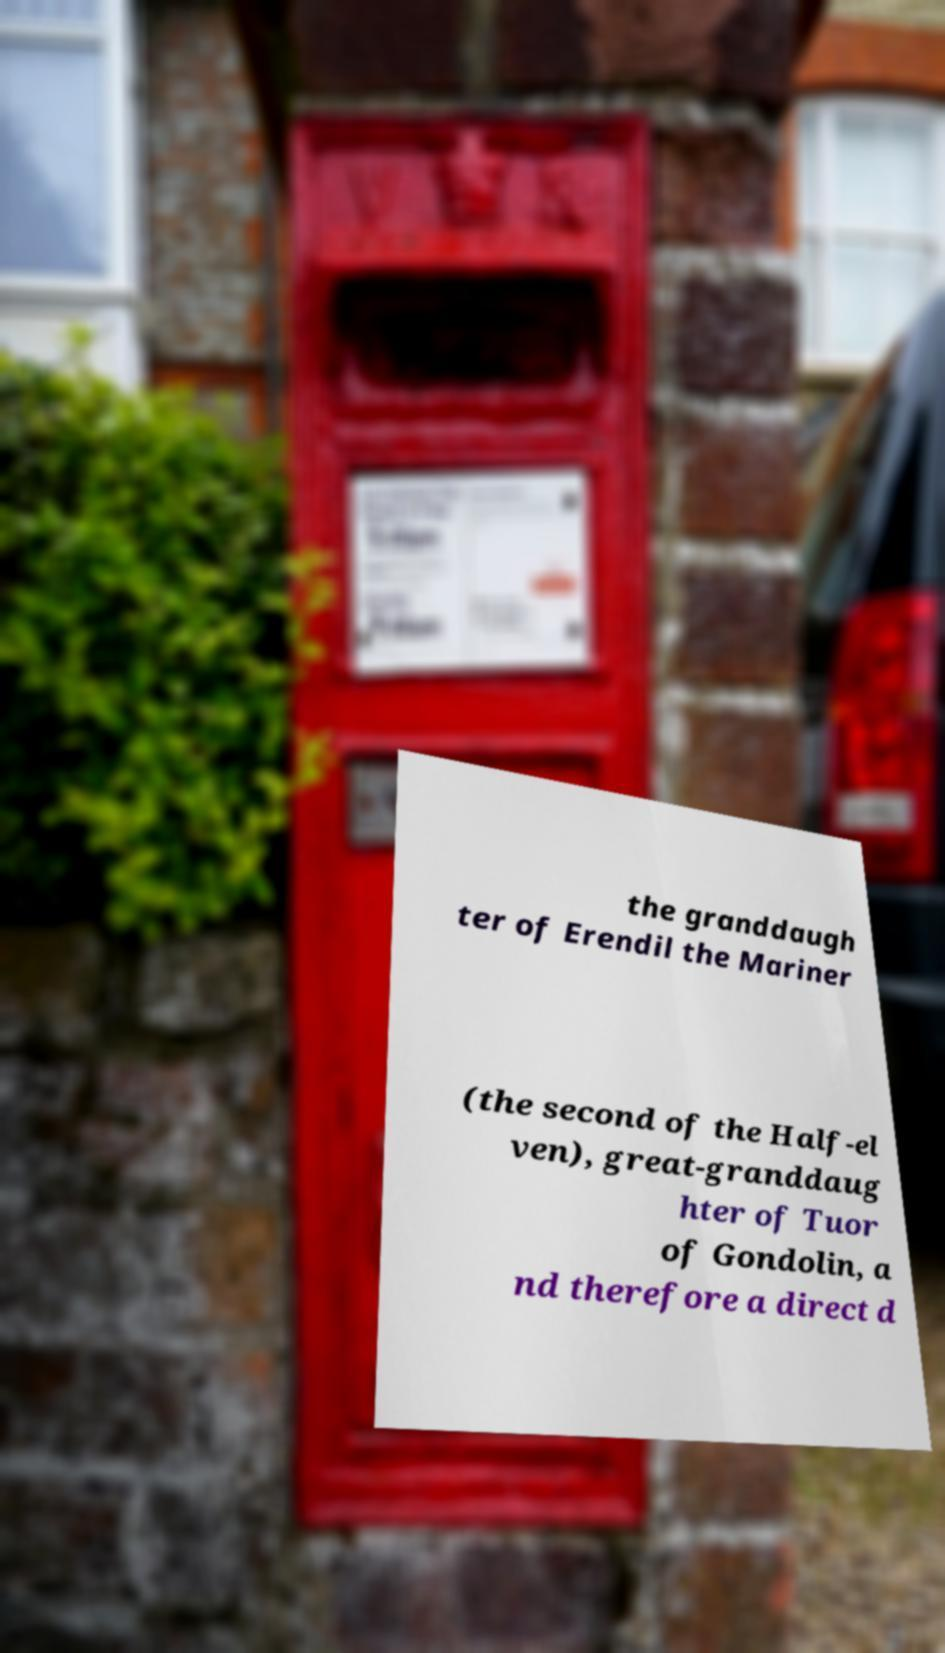What messages or text are displayed in this image? I need them in a readable, typed format. the granddaugh ter of Erendil the Mariner (the second of the Half-el ven), great-granddaug hter of Tuor of Gondolin, a nd therefore a direct d 